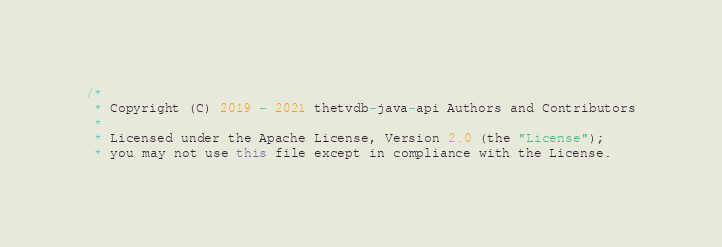Convert code to text. <code><loc_0><loc_0><loc_500><loc_500><_Java_>/*
 * Copyright (C) 2019 - 2021 thetvdb-java-api Authors and Contributors
 *
 * Licensed under the Apache License, Version 2.0 (the "License");
 * you may not use this file except in compliance with the License.</code> 